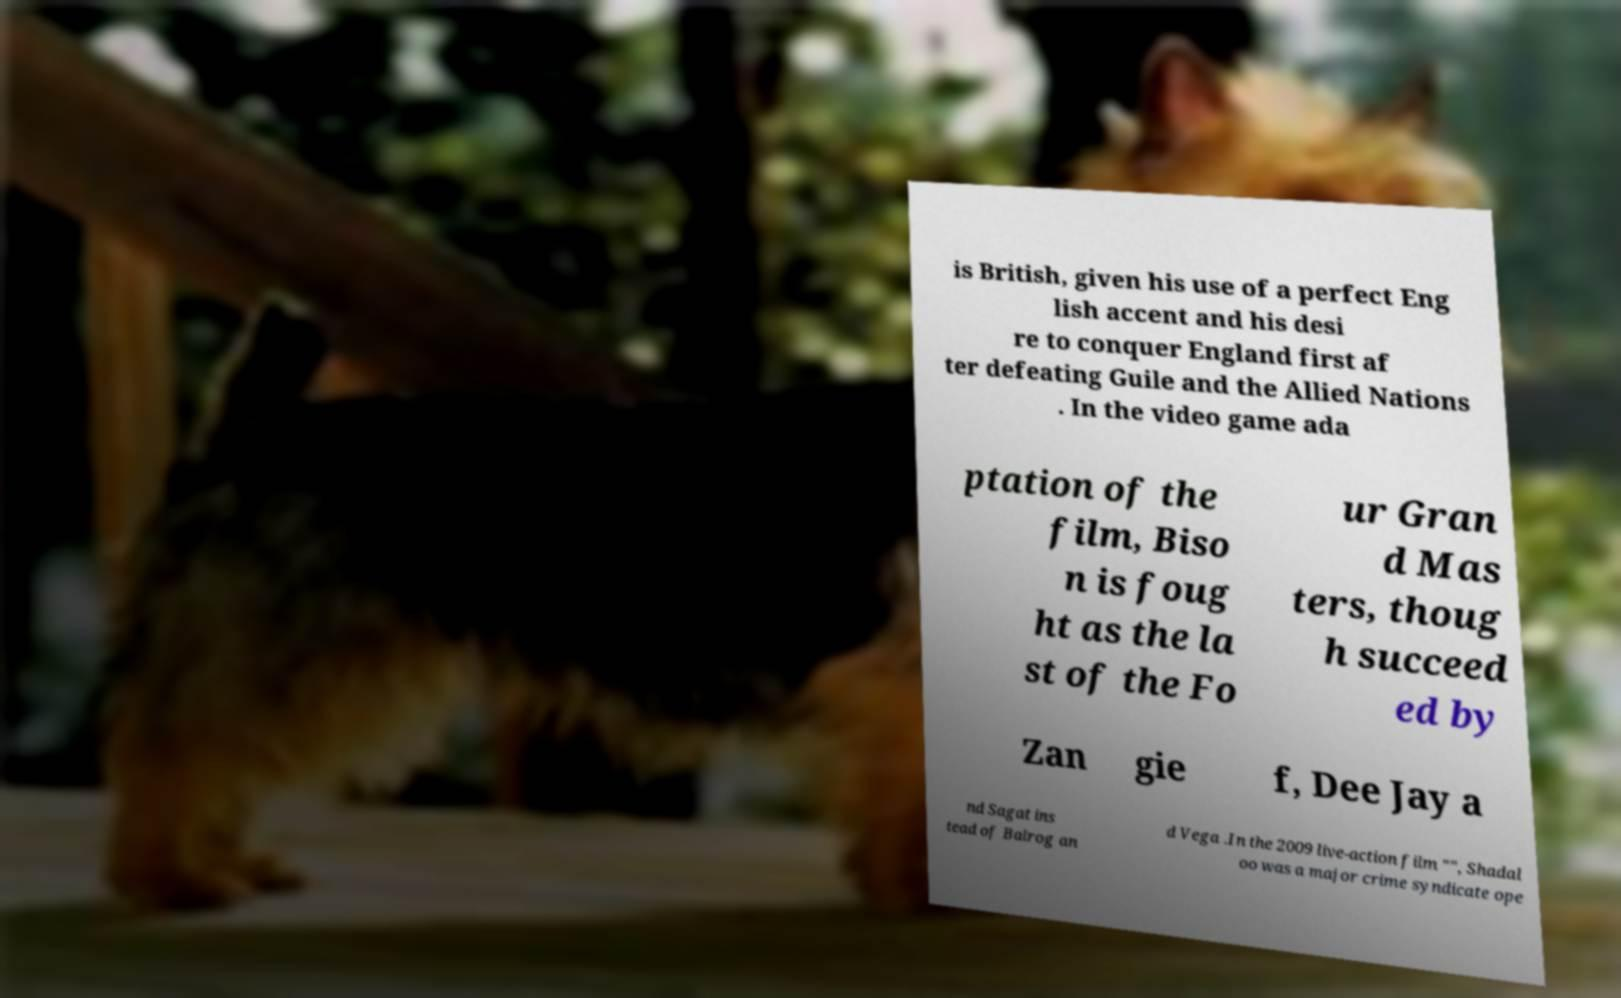I need the written content from this picture converted into text. Can you do that? is British, given his use of a perfect Eng lish accent and his desi re to conquer England first af ter defeating Guile and the Allied Nations . In the video game ada ptation of the film, Biso n is foug ht as the la st of the Fo ur Gran d Mas ters, thoug h succeed ed by Zan gie f, Dee Jay a nd Sagat ins tead of Balrog an d Vega .In the 2009 live-action film "", Shadal oo was a major crime syndicate ope 